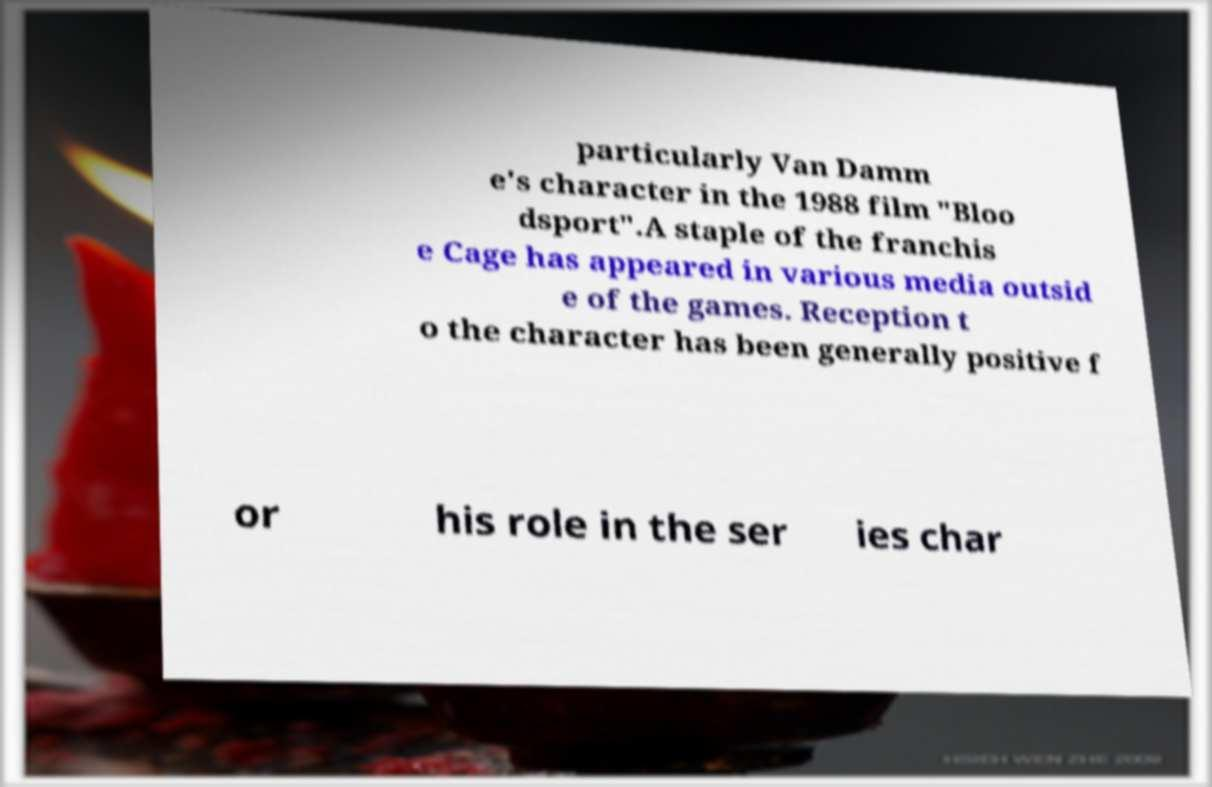What messages or text are displayed in this image? I need them in a readable, typed format. particularly Van Damm e's character in the 1988 film "Bloo dsport".A staple of the franchis e Cage has appeared in various media outsid e of the games. Reception t o the character has been generally positive f or his role in the ser ies char 